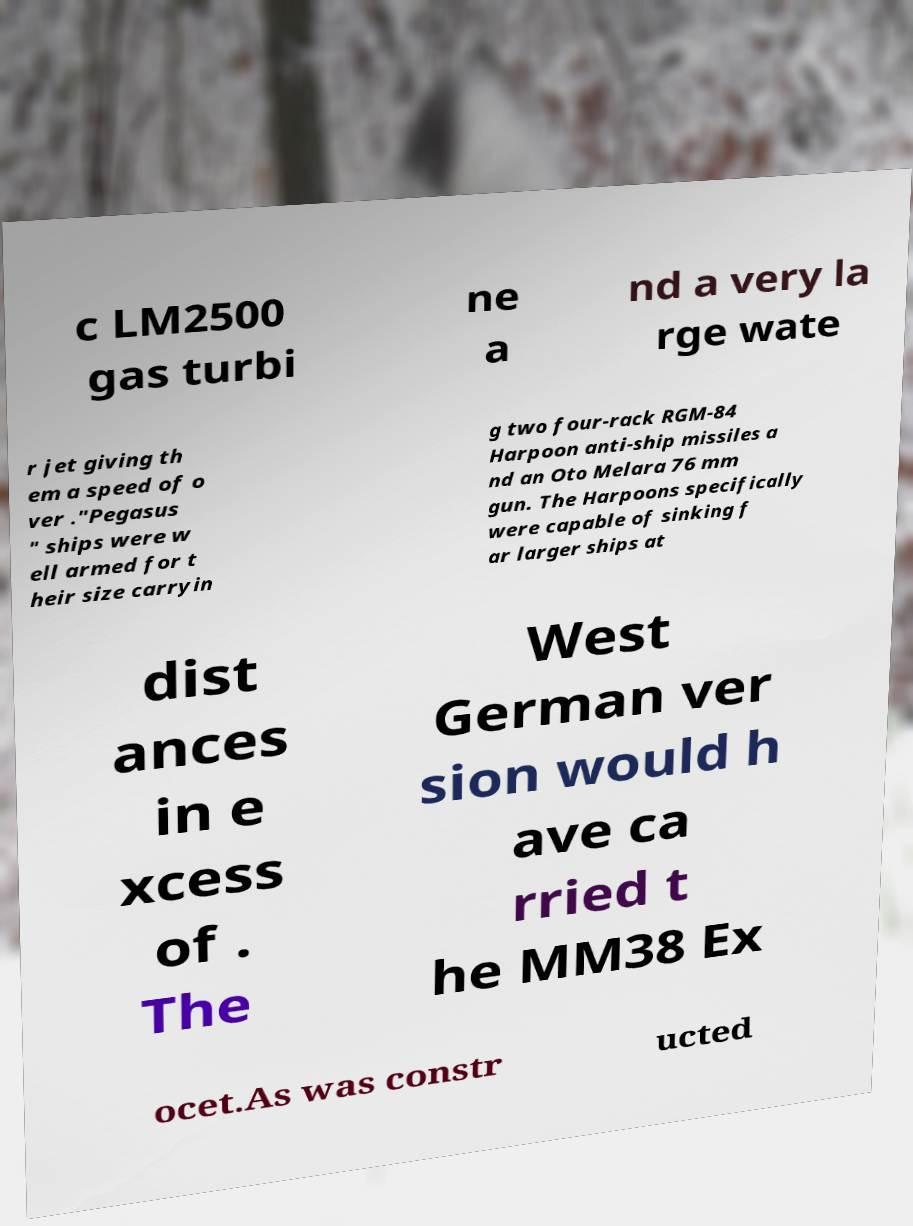Could you extract and type out the text from this image? c LM2500 gas turbi ne a nd a very la rge wate r jet giving th em a speed of o ver ."Pegasus " ships were w ell armed for t heir size carryin g two four-rack RGM-84 Harpoon anti-ship missiles a nd an Oto Melara 76 mm gun. The Harpoons specifically were capable of sinking f ar larger ships at dist ances in e xcess of . The West German ver sion would h ave ca rried t he MM38 Ex ocet.As was constr ucted 